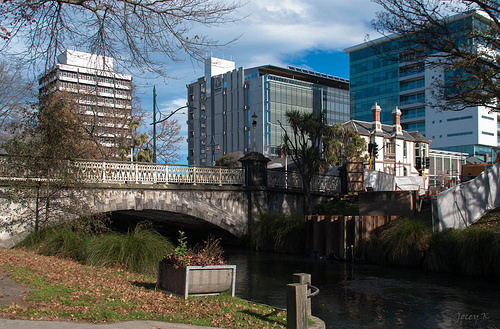<image>
Can you confirm if the tall grass is in front of the bridge? Yes. The tall grass is positioned in front of the bridge, appearing closer to the camera viewpoint. 